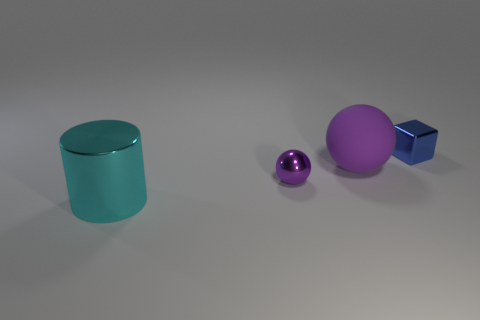What number of other objects are there of the same material as the small blue block?
Make the answer very short. 2. The shiny object that is in front of the purple object that is left of the purple object that is behind the purple metal ball is what color?
Provide a short and direct response. Cyan. What material is the blue object that is the same size as the shiny sphere?
Give a very brief answer. Metal. How many things are small metal things left of the tiny block or red shiny things?
Your response must be concise. 1. Is there a big rubber ball?
Ensure brevity in your answer.  Yes. What material is the small thing in front of the tiny blue cube?
Make the answer very short. Metal. What material is the object that is the same color as the small sphere?
Your answer should be compact. Rubber. What number of large objects are either green metal objects or cyan metal things?
Give a very brief answer. 1. What color is the cube?
Give a very brief answer. Blue. Is there a big object left of the tiny thing that is in front of the block?
Provide a short and direct response. Yes. 